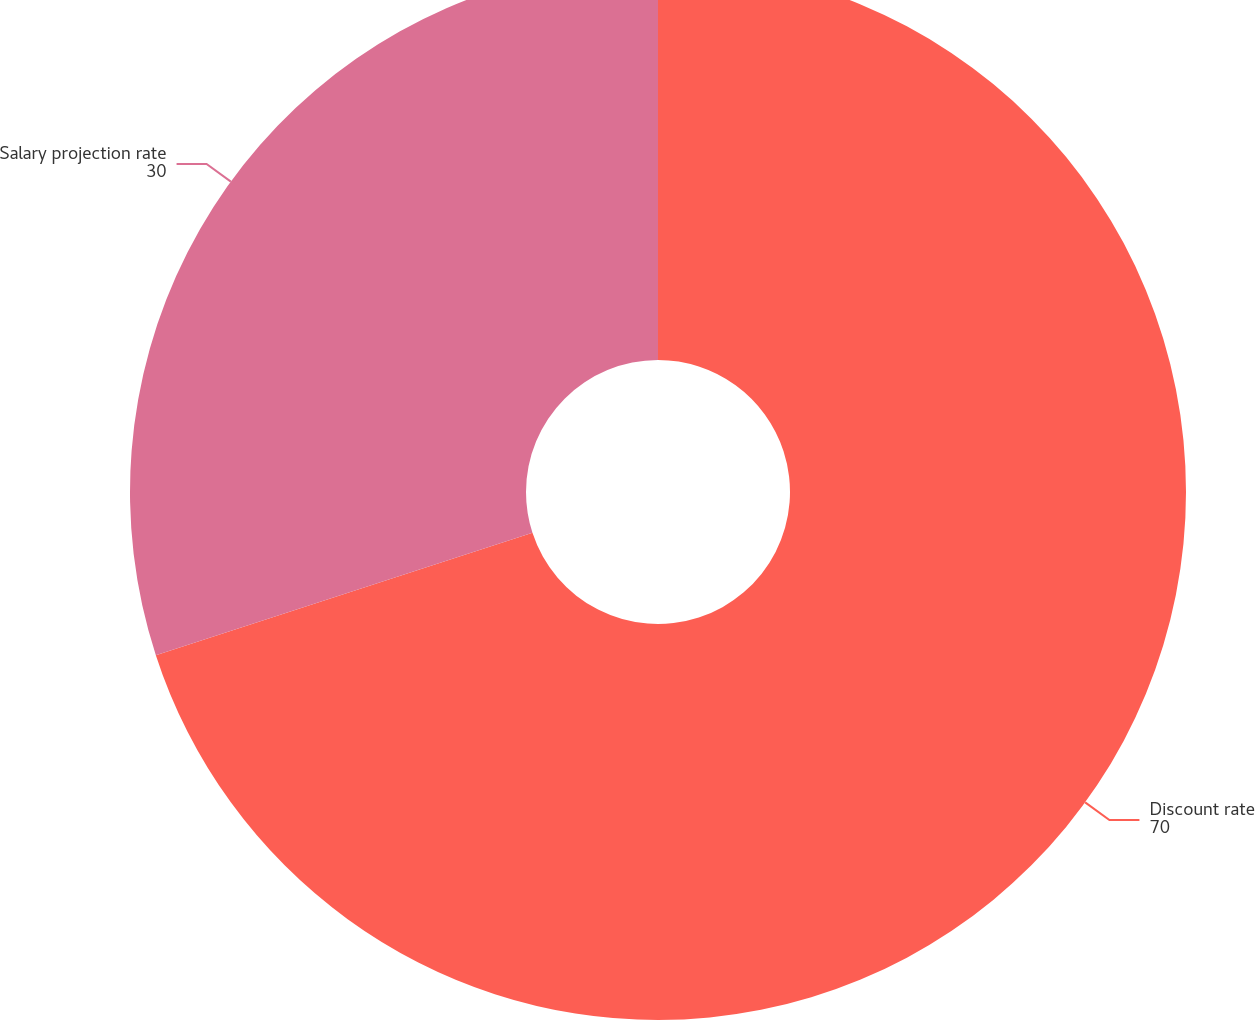Convert chart to OTSL. <chart><loc_0><loc_0><loc_500><loc_500><pie_chart><fcel>Discount rate<fcel>Salary projection rate<nl><fcel>70.0%<fcel>30.0%<nl></chart> 